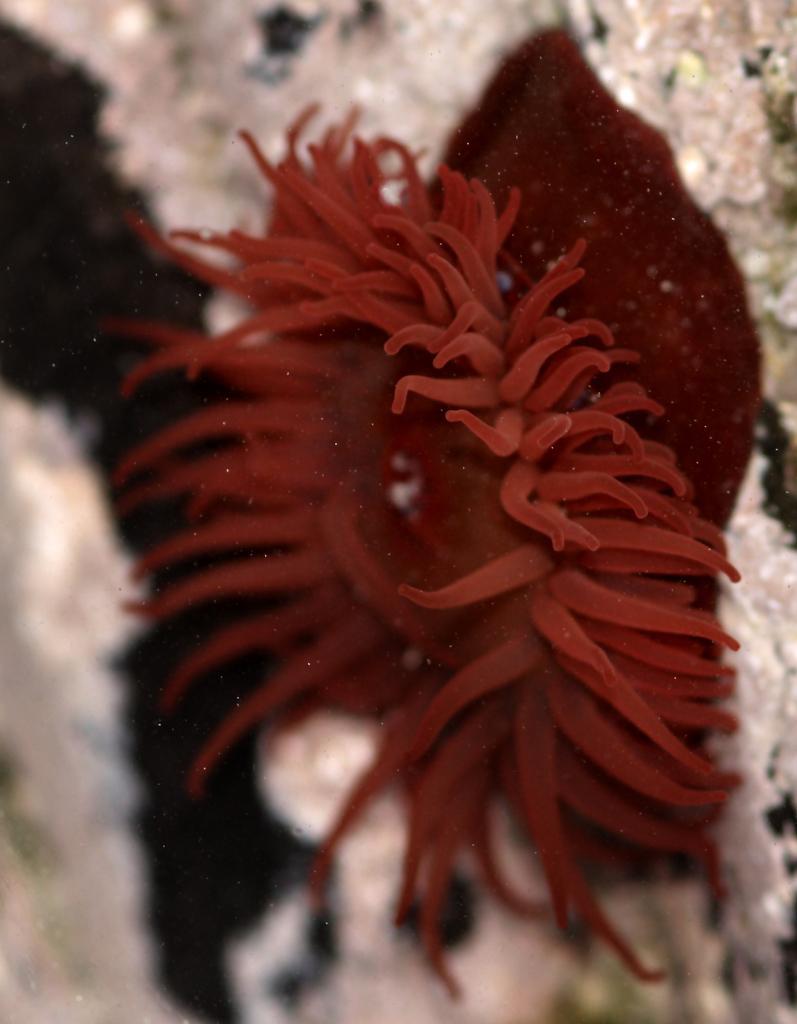Describe this image in one or two sentences. In this picture there is a sea creature sitting on the coral stones. 